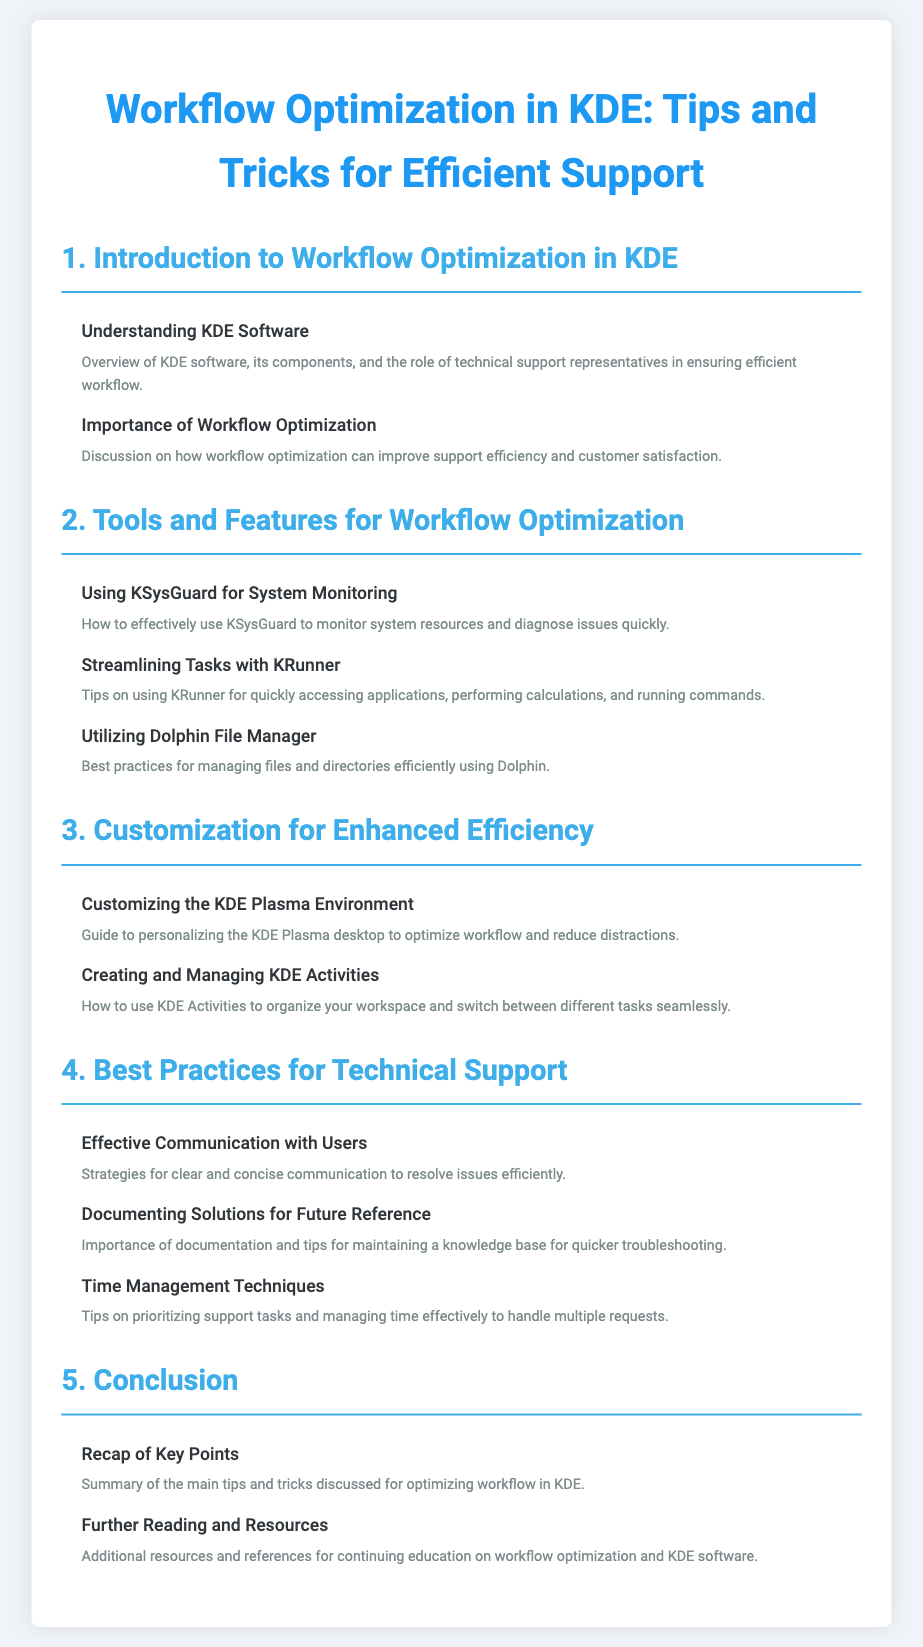what is the title of the document? The title is explicitly stated at the top of the document.
Answer: Workflow Optimization in KDE: Tips and Tricks for Efficient Support how many main sections are there in the document? The number of main sections can be counted in the table of contents.
Answer: 5 which section discusses customization? The section titles provide an overview of their content, and we can find customization in the third section.
Answer: Customization for Enhanced Efficiency what is the focus of section 4? The section headings guide the reader in understanding the main topics, which are related to technical support.
Answer: Best Practices for Technical Support what tool is mentioned for system monitoring? Specific tools are referenced in section 2, where KSysGuard is highlighted.
Answer: KSysGuard which technique is suggested for efficient time management? The section titles summarize the content, indicating techniques for managing support tasks effectively.
Answer: Time Management Techniques what is the first topic under the introduction? The topics listed under each section help to identify the first topic in the introduction section.
Answer: Understanding KDE Software how does section 5 conclude the document? The conclusion section summarizes the key points we're expected to remember from the preceding content.
Answer: Recap of Key Points 